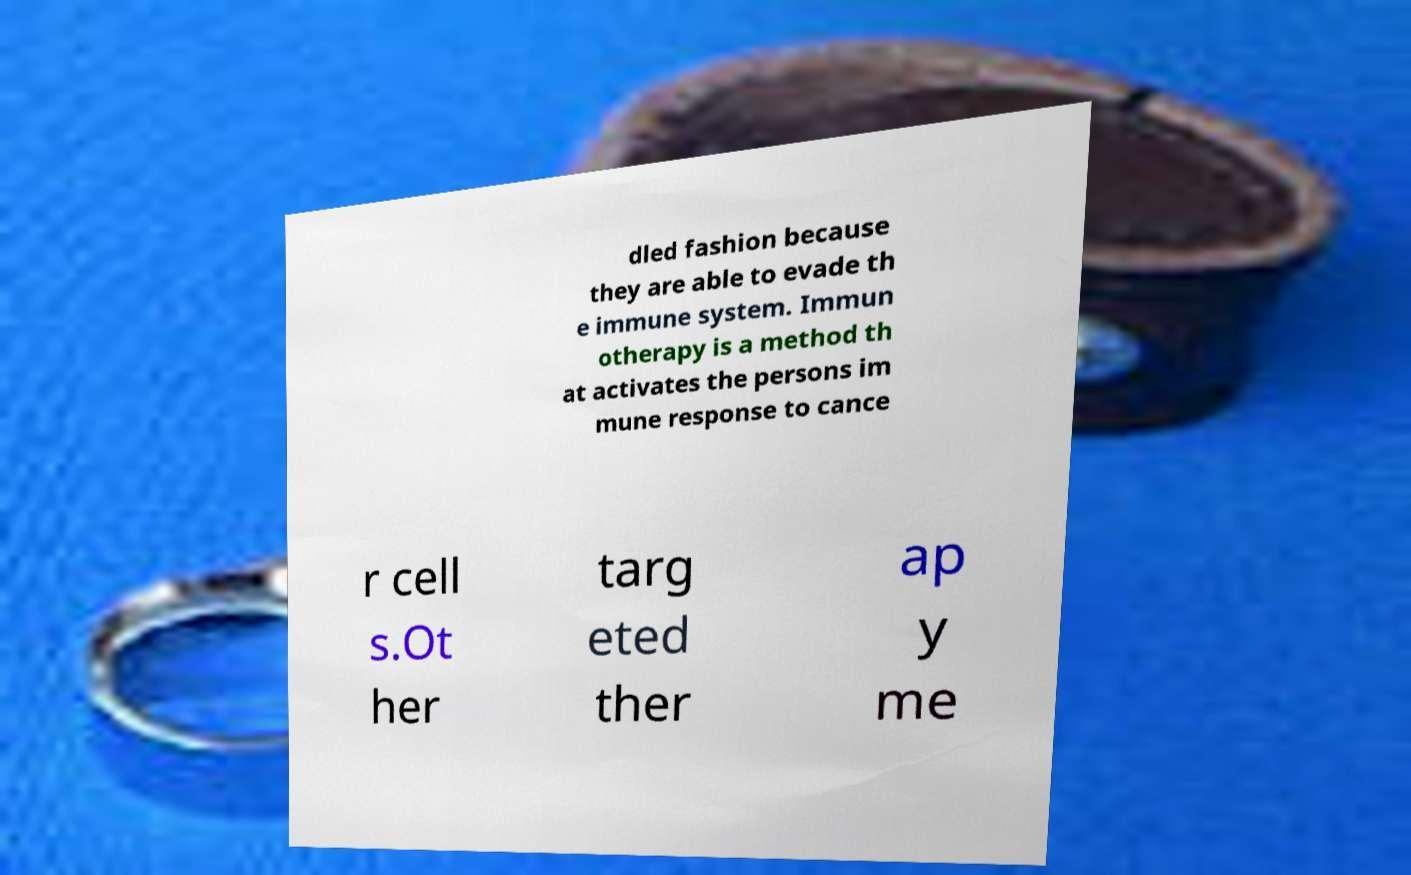There's text embedded in this image that I need extracted. Can you transcribe it verbatim? dled fashion because they are able to evade th e immune system. Immun otherapy is a method th at activates the persons im mune response to cance r cell s.Ot her targ eted ther ap y me 